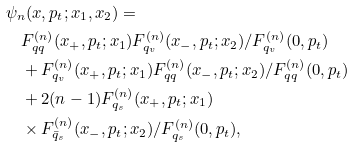Convert formula to latex. <formula><loc_0><loc_0><loc_500><loc_500>& \psi _ { n } ( x , p _ { t } ; x _ { 1 } , x _ { 2 } ) = \\ & \quad F _ { q q } ^ { ( n ) } ( x _ { + } , p _ { t } ; x _ { 1 } ) F _ { q _ { v } } ^ { ( n ) } ( x _ { - } , p _ { t } ; x _ { 2 } ) / F _ { q _ { v } } ^ { ( n ) } ( 0 , p _ { t } ) \\ & \quad + F _ { q _ { v } } ^ { ( n ) } ( x _ { + } , p _ { t } ; x _ { 1 } ) F _ { q q } ^ { ( n ) } ( x _ { - } , p _ { t } ; x _ { 2 } ) / F _ { q q } ^ { ( n ) } ( 0 , p _ { t } ) \\ & \quad + 2 ( n - 1 ) F _ { q _ { s } } ^ { ( n ) } ( x _ { + } , p _ { t } ; x _ { 1 } ) \\ & \quad \times F _ { { \bar { q } } _ { s } } ^ { ( n ) } ( x _ { - } , p _ { t } ; x _ { 2 } ) / F _ { q _ { s } } ^ { ( n ) } ( 0 , p _ { t } ) ,</formula> 